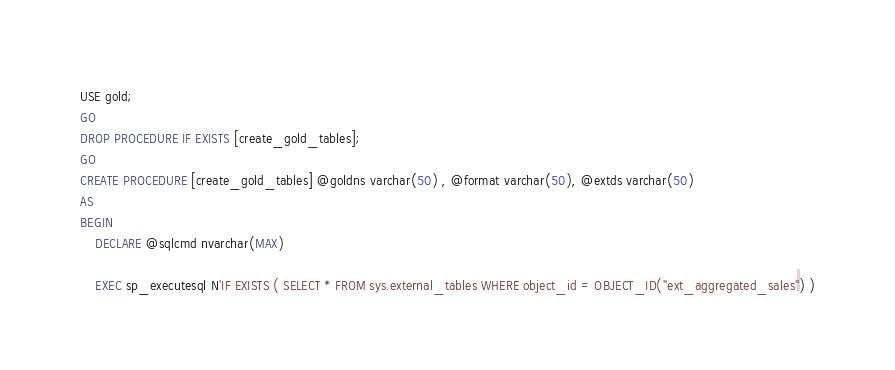<code> <loc_0><loc_0><loc_500><loc_500><_SQL_>USE gold;
GO
DROP PROCEDURE IF EXISTS [create_gold_tables];
GO
CREATE PROCEDURE [create_gold_tables] @goldns varchar(50) , @format varchar(50), @extds varchar(50)
AS
BEGIN
    DECLARE @sqlcmd nvarchar(MAX)
    
    EXEC sp_executesql N'IF EXISTS ( SELECT * FROM sys.external_tables WHERE object_id = OBJECT_ID(''ext_aggregated_sales'') )</code> 